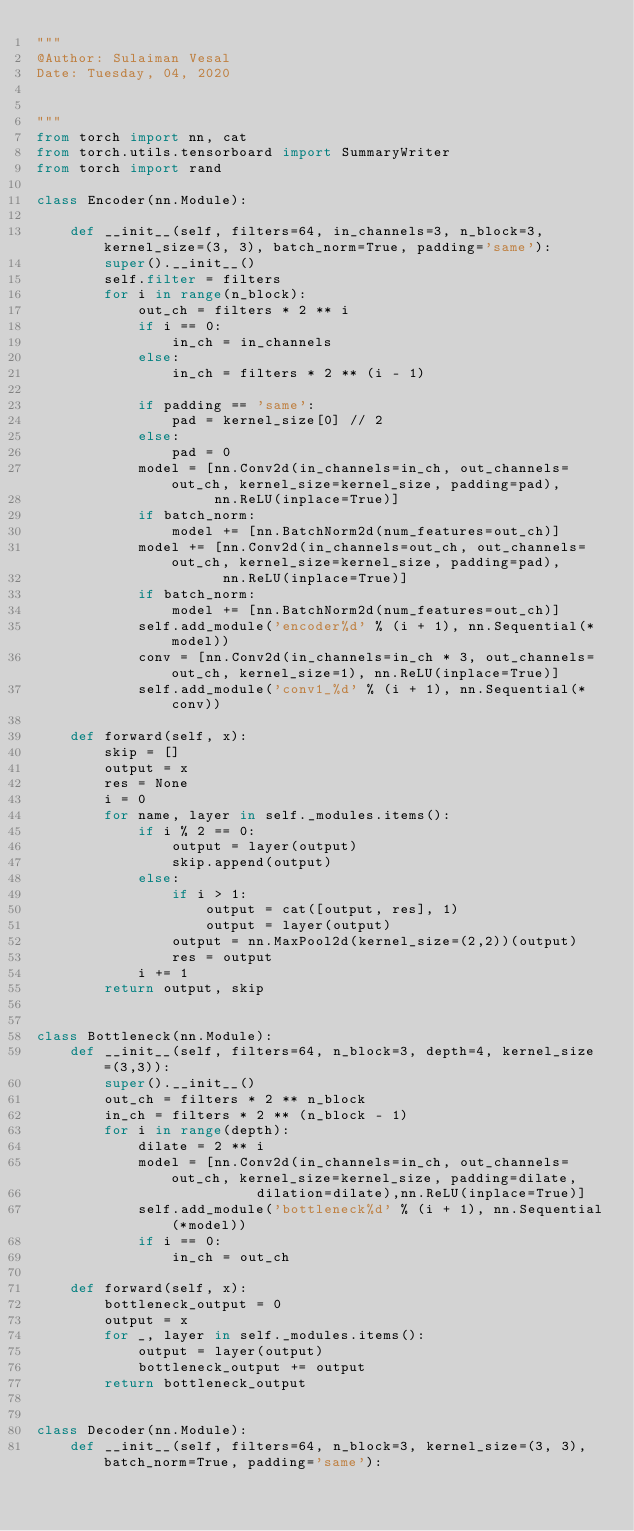Convert code to text. <code><loc_0><loc_0><loc_500><loc_500><_Python_>"""
@Author: Sulaiman Vesal
Date: Tuesday, 04, 2020


"""
from torch import nn, cat
from torch.utils.tensorboard import SummaryWriter
from torch import rand

class Encoder(nn.Module):

    def __init__(self, filters=64, in_channels=3, n_block=3, kernel_size=(3, 3), batch_norm=True, padding='same'):
        super().__init__()
        self.filter = filters
        for i in range(n_block):
            out_ch = filters * 2 ** i
            if i == 0:
                in_ch = in_channels
            else:
                in_ch = filters * 2 ** (i - 1)

            if padding == 'same':
                pad = kernel_size[0] // 2
            else:
                pad = 0
            model = [nn.Conv2d(in_channels=in_ch, out_channels=out_ch, kernel_size=kernel_size, padding=pad),
                     nn.ReLU(inplace=True)]
            if batch_norm:
                model += [nn.BatchNorm2d(num_features=out_ch)]
            model += [nn.Conv2d(in_channels=out_ch, out_channels=out_ch, kernel_size=kernel_size, padding=pad),
                      nn.ReLU(inplace=True)]
            if batch_norm:
                model += [nn.BatchNorm2d(num_features=out_ch)]
            self.add_module('encoder%d' % (i + 1), nn.Sequential(*model))
            conv = [nn.Conv2d(in_channels=in_ch * 3, out_channels=out_ch, kernel_size=1), nn.ReLU(inplace=True)]
            self.add_module('conv1_%d' % (i + 1), nn.Sequential(*conv))

    def forward(self, x):
        skip = []
        output = x
        res = None
        i = 0
        for name, layer in self._modules.items():
            if i % 2 == 0:
                output = layer(output)
                skip.append(output)
            else:
                if i > 1:
                    output = cat([output, res], 1)
                    output = layer(output)
                output = nn.MaxPool2d(kernel_size=(2,2))(output)
                res = output
            i += 1
        return output, skip


class Bottleneck(nn.Module):
    def __init__(self, filters=64, n_block=3, depth=4, kernel_size=(3,3)):
        super().__init__()
        out_ch = filters * 2 ** n_block
        in_ch = filters * 2 ** (n_block - 1)
        for i in range(depth):
            dilate = 2 ** i
            model = [nn.Conv2d(in_channels=in_ch, out_channels=out_ch, kernel_size=kernel_size, padding=dilate,
                          dilation=dilate),nn.ReLU(inplace=True)]
            self.add_module('bottleneck%d' % (i + 1), nn.Sequential(*model))
            if i == 0:
                in_ch = out_ch

    def forward(self, x):
        bottleneck_output = 0
        output = x
        for _, layer in self._modules.items():
            output = layer(output)
            bottleneck_output += output
        return bottleneck_output


class Decoder(nn.Module):
    def __init__(self, filters=64, n_block=3, kernel_size=(3, 3), batch_norm=True, padding='same'):</code> 